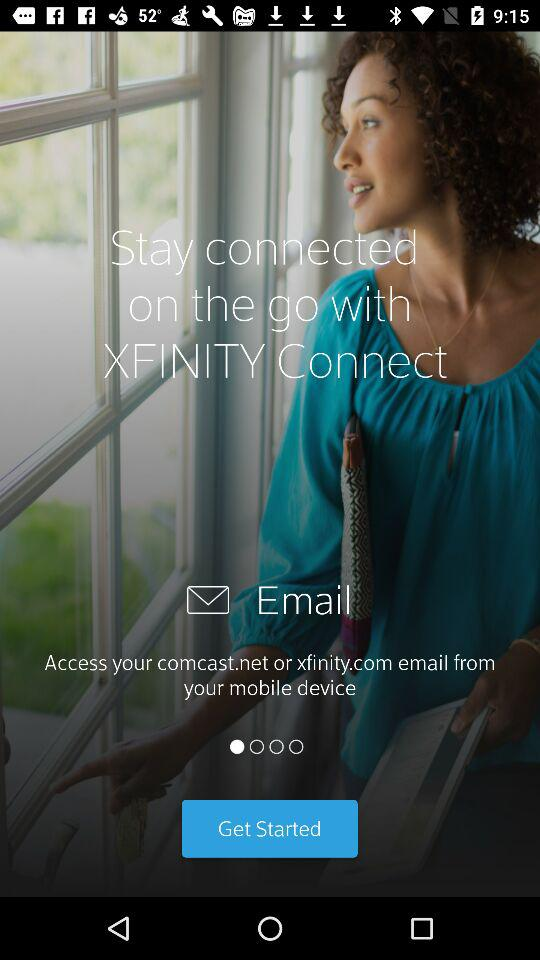What is the application name? The application name is "XFINITY Connect". 